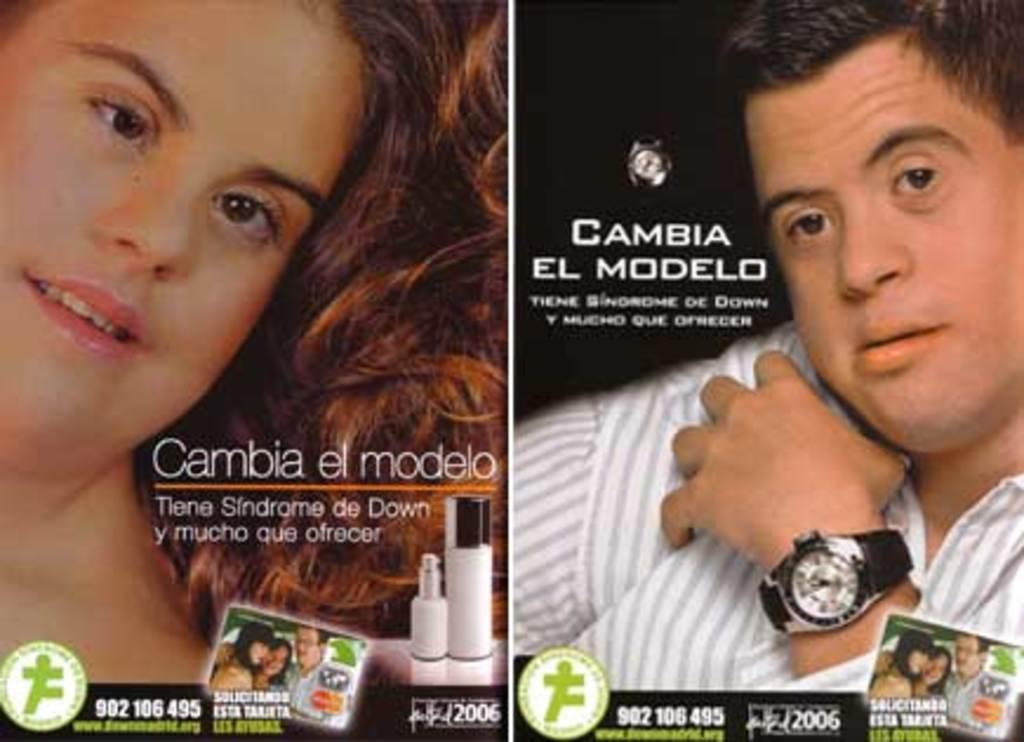<image>
Create a compact narrative representing the image presented. two people in an ad for Cambia El Modelo look at the camera 